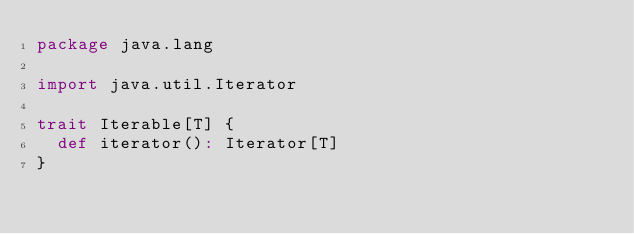<code> <loc_0><loc_0><loc_500><loc_500><_Scala_>package java.lang

import java.util.Iterator

trait Iterable[T] {
  def iterator(): Iterator[T]
}
</code> 